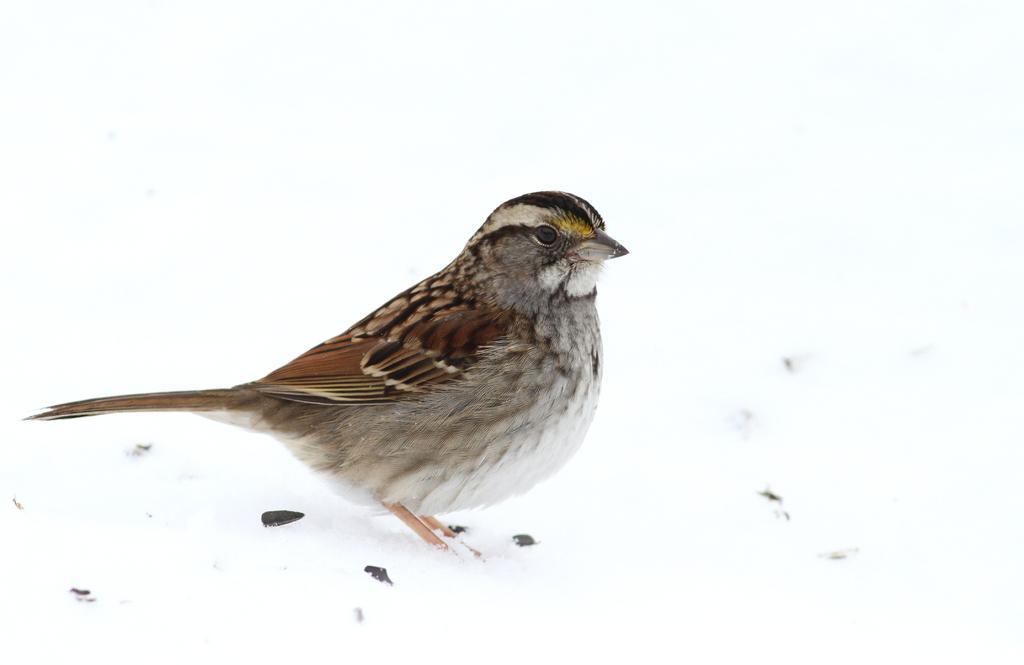Describe this image in one or two sentences. In this image we can see a bird on the ground. We can also see the snow on the ground. 